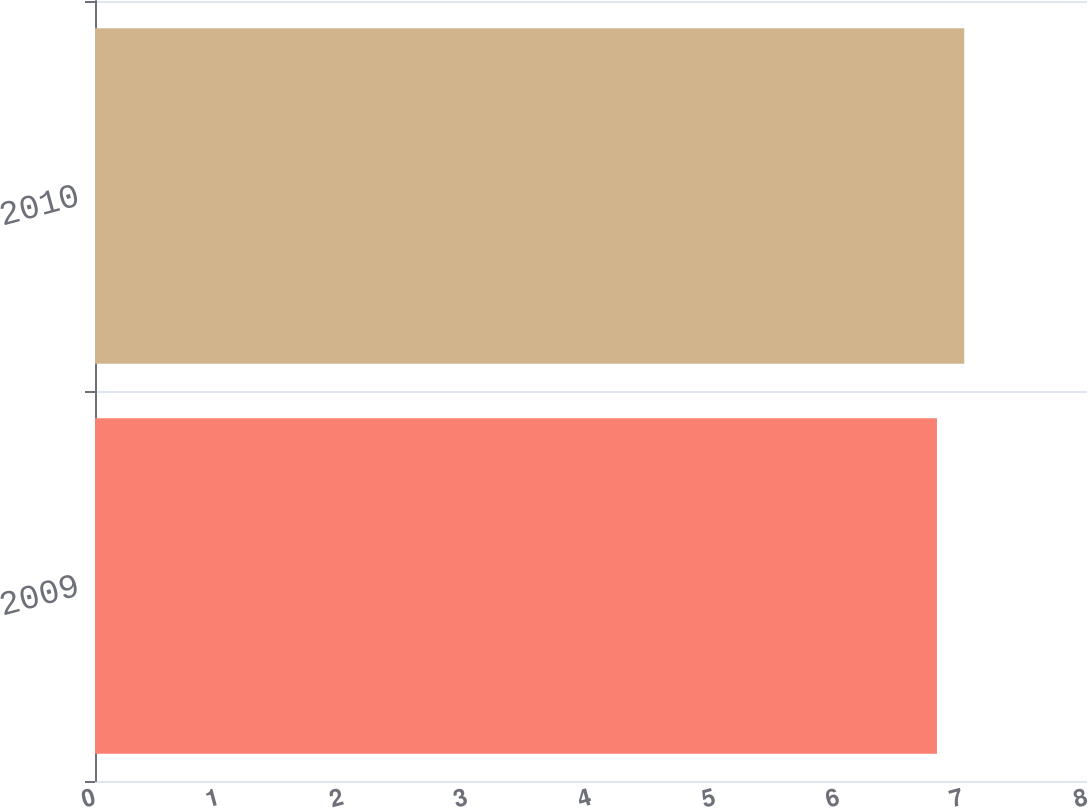Convert chart. <chart><loc_0><loc_0><loc_500><loc_500><bar_chart><fcel>2009<fcel>2010<nl><fcel>6.79<fcel>7.01<nl></chart> 